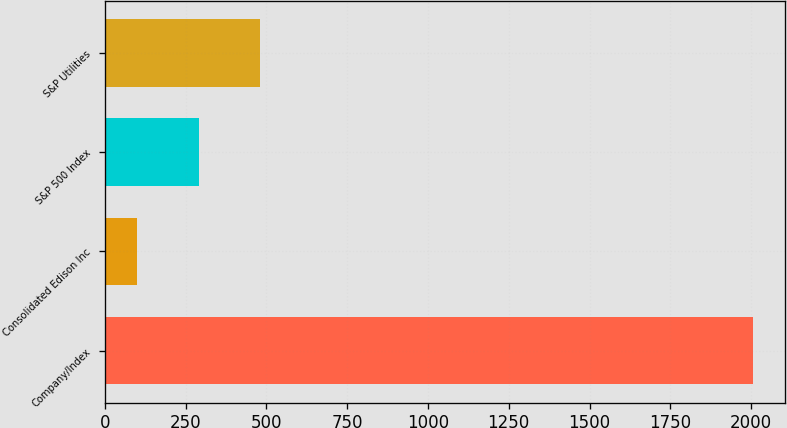Convert chart to OTSL. <chart><loc_0><loc_0><loc_500><loc_500><bar_chart><fcel>Company/Index<fcel>Consolidated Edison Inc<fcel>S&P 500 Index<fcel>S&P Utilities<nl><fcel>2006<fcel>100<fcel>290.6<fcel>481.2<nl></chart> 